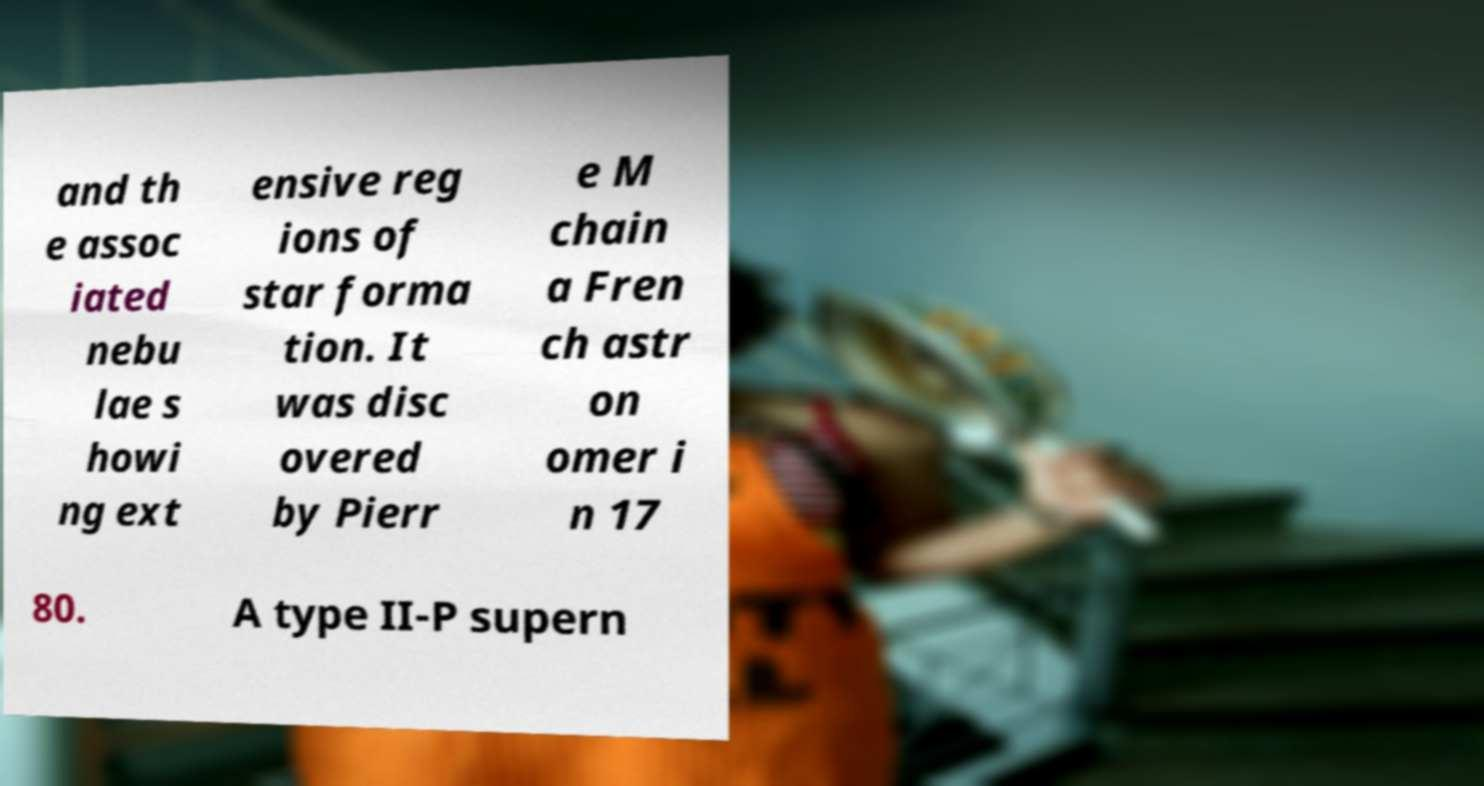Can you read and provide the text displayed in the image?This photo seems to have some interesting text. Can you extract and type it out for me? and th e assoc iated nebu lae s howi ng ext ensive reg ions of star forma tion. It was disc overed by Pierr e M chain a Fren ch astr on omer i n 17 80. A type II-P supern 